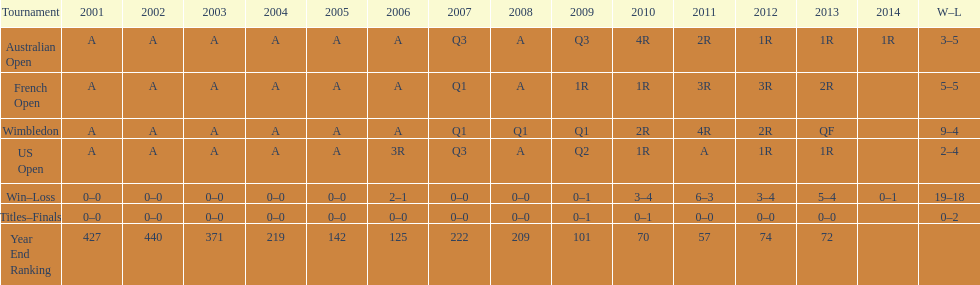In how many contests were 5 total losses experienced? 2. 